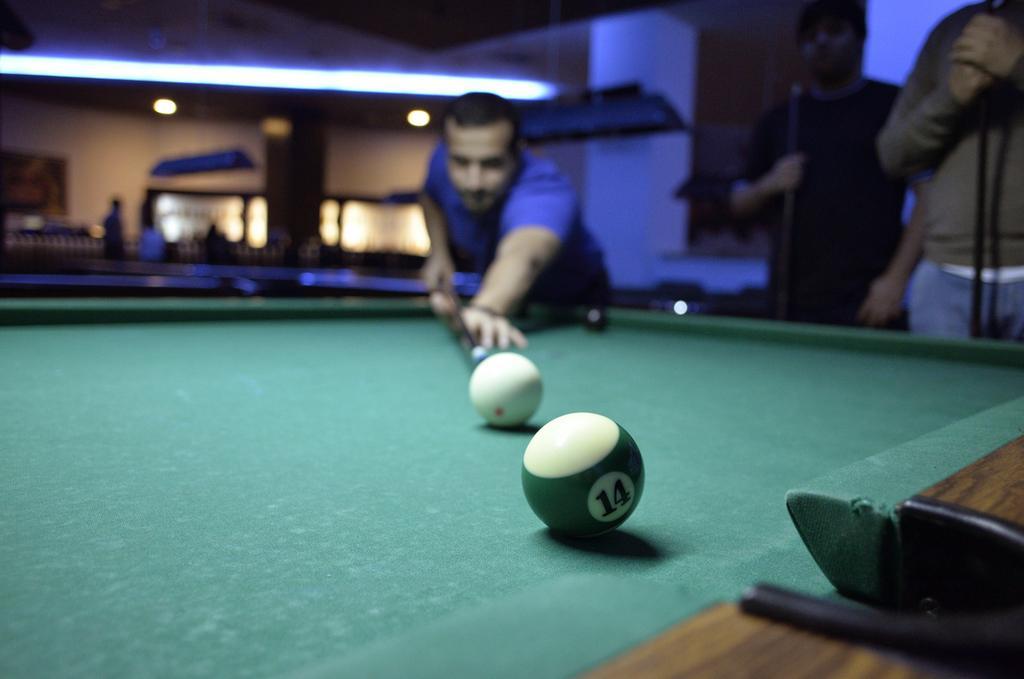In one or two sentences, can you explain what this image depicts? In the foreground I can see a person is playing a snooker on the table. In the background I can see a group of people, lights, wall and a building. This image is taken may be during night. 